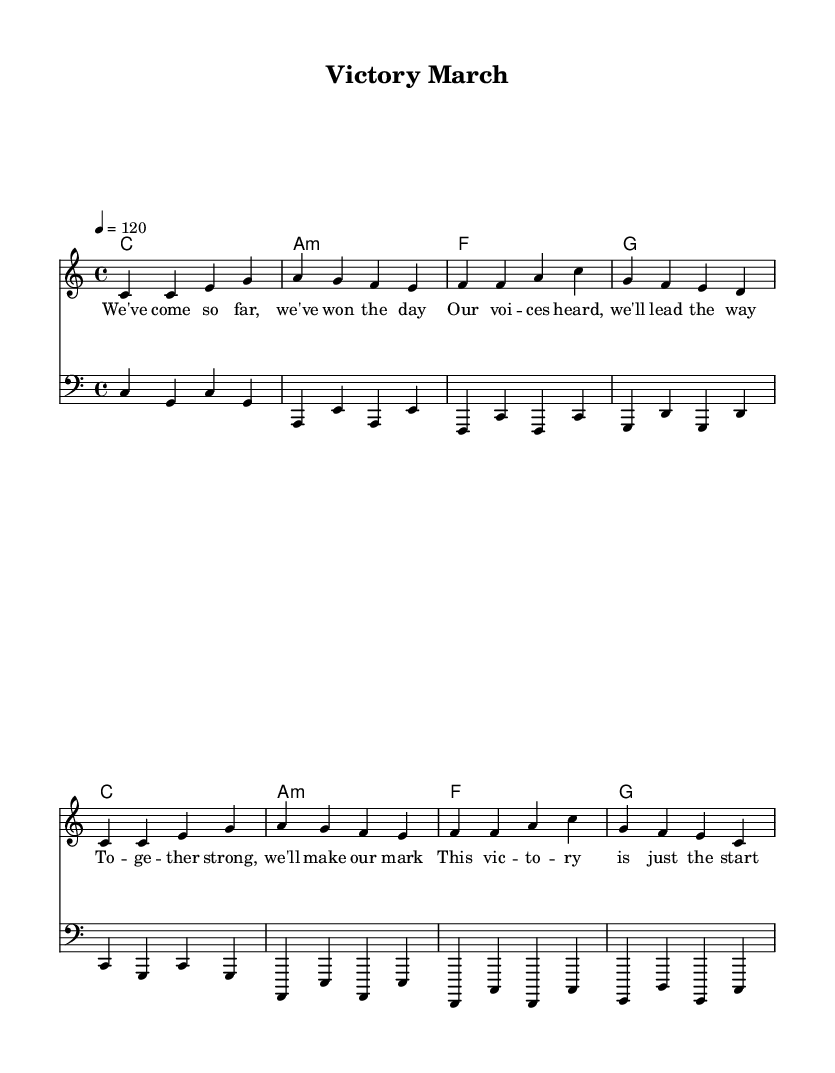What is the key signature of this music? The key signature indicated by the global variable states that the piece is in C major, which has no sharps or flats. You can see this at the beginning of the sheet music.
Answer: C major What is the time signature of this piece? The time signature is represented as 4/4 in the global variable. This means there are four beats in a measure and the quarter note receives one beat.
Answer: 4/4 What is the tempo marking? The tempo is indicated in the global variable as "4 = 120," meaning the quarter note is played at a speed of 120 beats per minute. This can be verified in the tempo section at the top of the sheet music.
Answer: 120 How many measures are in the melody? Counting the measures in the melody, there are eight measures. This can be determined by recognizing the separation of rhythmic groupings in the melody staff.
Answer: 8 What type of song is this? Given the elements within the sheet music, including the upbeat tempo and celebratory lyrics, this piece is categorized as a pop song, specifically designed to celebrate political victories and milestones.
Answer: Pop Which chord is used in the first measure? The first measure of the harmonies section indicates a C major chord, which is identified by the letter "c" in the chord mode section.
Answer: C major What is the overall mood conveyed by the lyrics? The lyrics suggest an uplifting and victorious mood, highlighting themes of success and collective strength, which is characteristic of celebratory pop songs.
Answer: Uplifting 